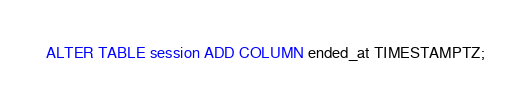<code> <loc_0><loc_0><loc_500><loc_500><_SQL_>ALTER TABLE session ADD COLUMN ended_at TIMESTAMPTZ;</code> 